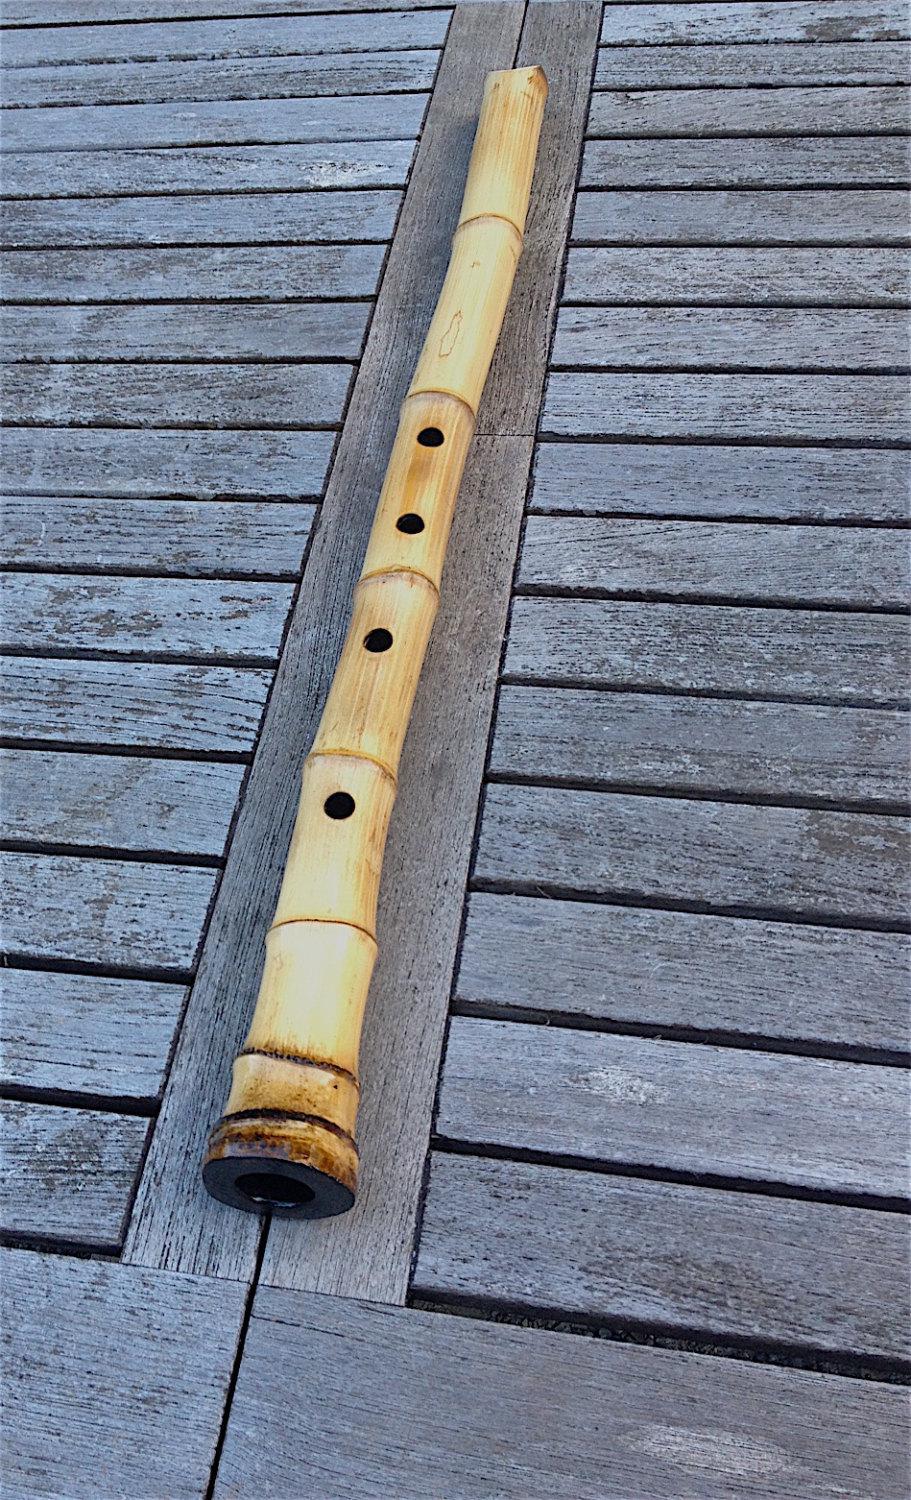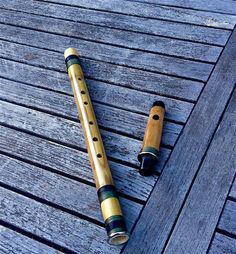The first image is the image on the left, the second image is the image on the right. Given the left and right images, does the statement "At least 2 flutes are laying on a wood plank table." hold true? Answer yes or no. Yes. 